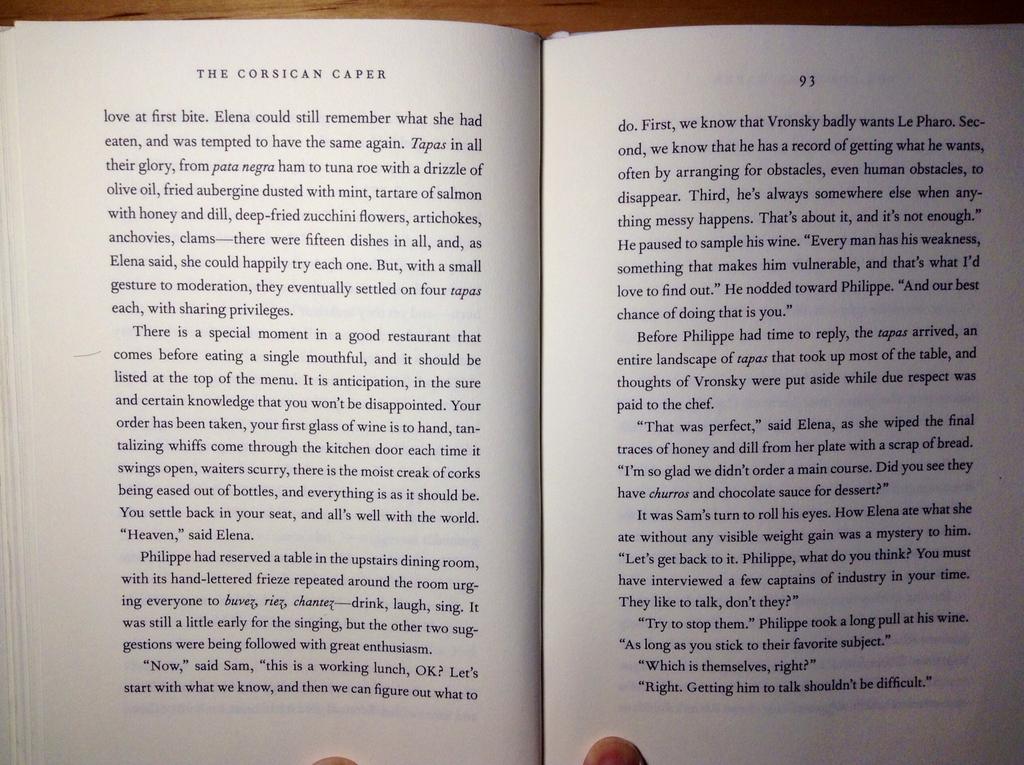What chapter are they reading?
Keep it short and to the point. The corsican caper. The page number on the right is?
Keep it short and to the point. 93. 